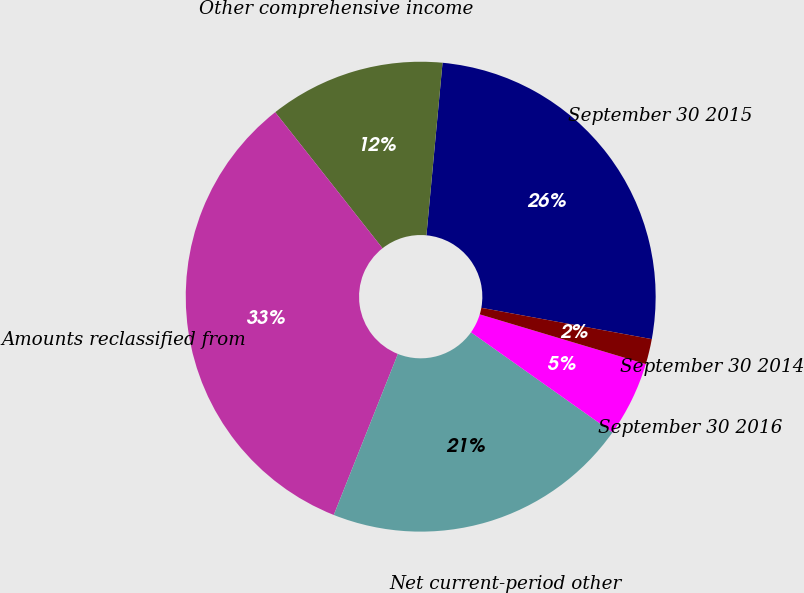Convert chart to OTSL. <chart><loc_0><loc_0><loc_500><loc_500><pie_chart><fcel>September 30 2015<fcel>Other comprehensive income<fcel>Amounts reclassified from<fcel>Net current-period other<fcel>September 30 2016<fcel>September 30 2014<nl><fcel>26.41%<fcel>12.11%<fcel>33.34%<fcel>21.23%<fcel>5.17%<fcel>1.74%<nl></chart> 